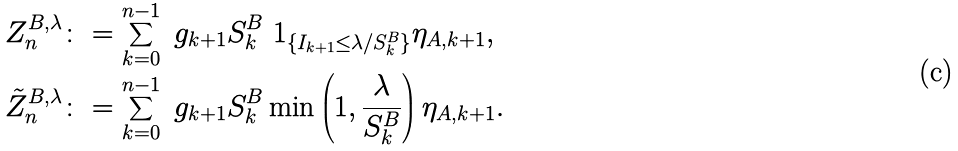<formula> <loc_0><loc_0><loc_500><loc_500>Z _ { n } ^ { B , \lambda } & \colon = \sum _ { k = 0 } ^ { n - 1 } \ g _ { k + 1 } S _ { k } ^ { B } \ 1 _ { \{ I _ { k + 1 } \leq \lambda / S _ { k } ^ { B } \} } \eta _ { A , k + 1 } , \\ { \tilde { Z } } _ { n } ^ { B , \lambda } & \colon = \sum _ { k = 0 } ^ { n - 1 } \ g _ { k + 1 } S _ { k } ^ { B } \min \left ( 1 , \frac { \lambda } { S _ { k } ^ { B } } \right ) \eta _ { A , k + 1 } .</formula> 